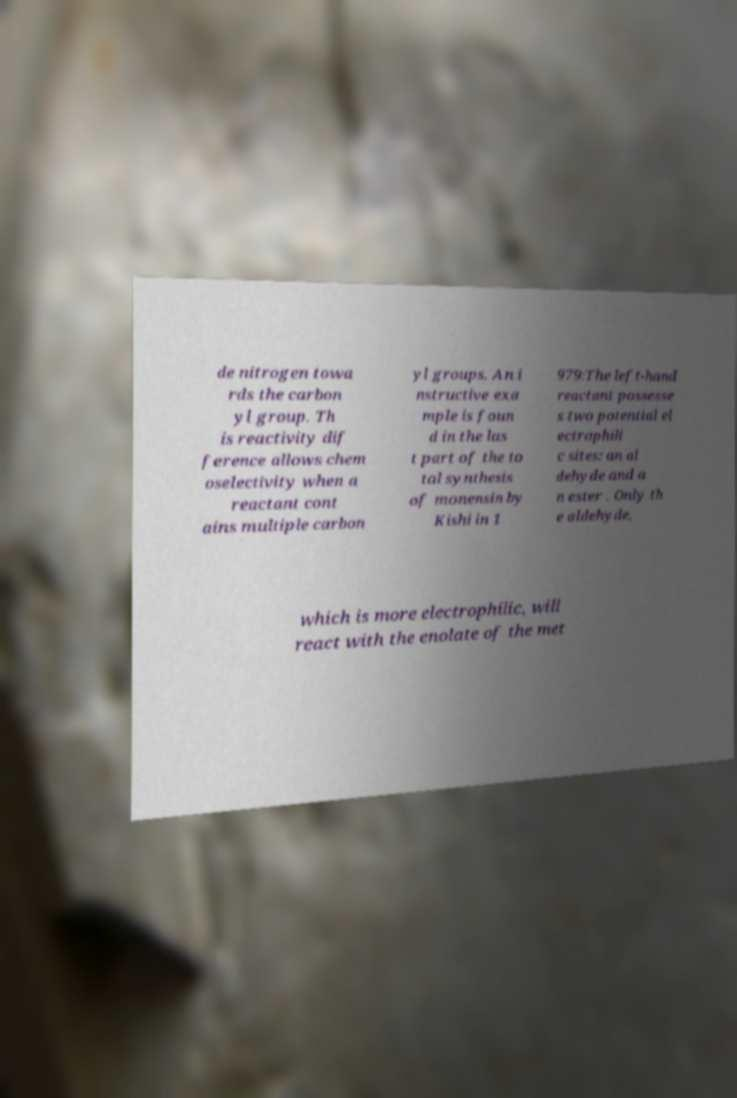Could you extract and type out the text from this image? de nitrogen towa rds the carbon yl group. Th is reactivity dif ference allows chem oselectivity when a reactant cont ains multiple carbon yl groups. An i nstructive exa mple is foun d in the las t part of the to tal synthesis of monensin by Kishi in 1 979:The left-hand reactant possesse s two potential el ectrophili c sites: an al dehyde and a n ester . Only th e aldehyde, which is more electrophilic, will react with the enolate of the met 